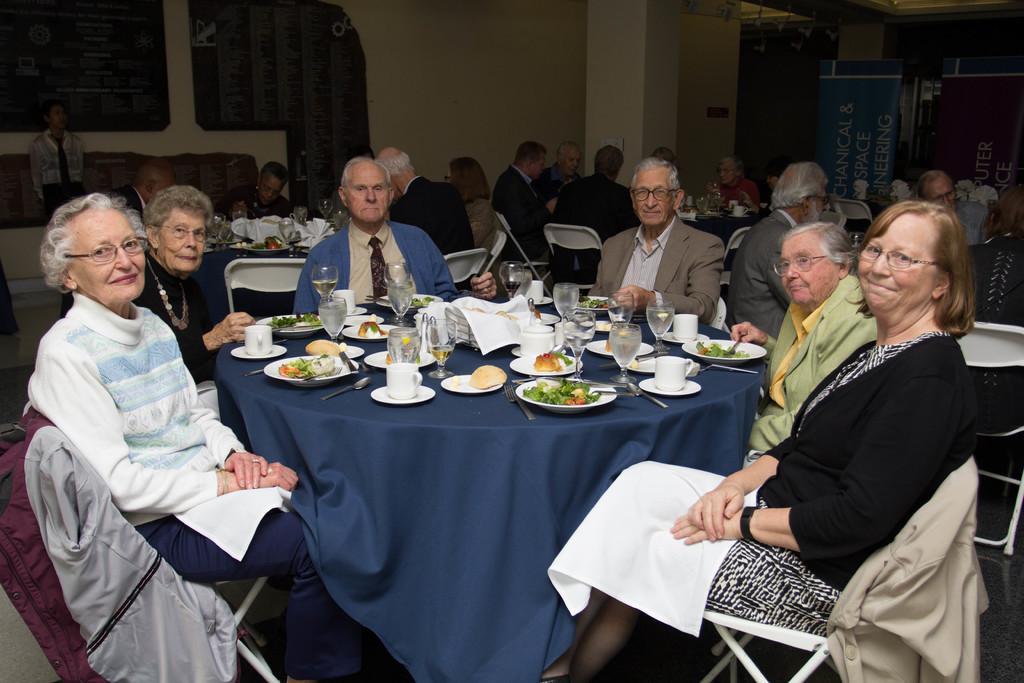Could you give a brief overview of what you see in this image? In this image i can see a group of people sitting there are few glasses, plates, food on a table at the back ground i can see few other people sitting and a wall. 